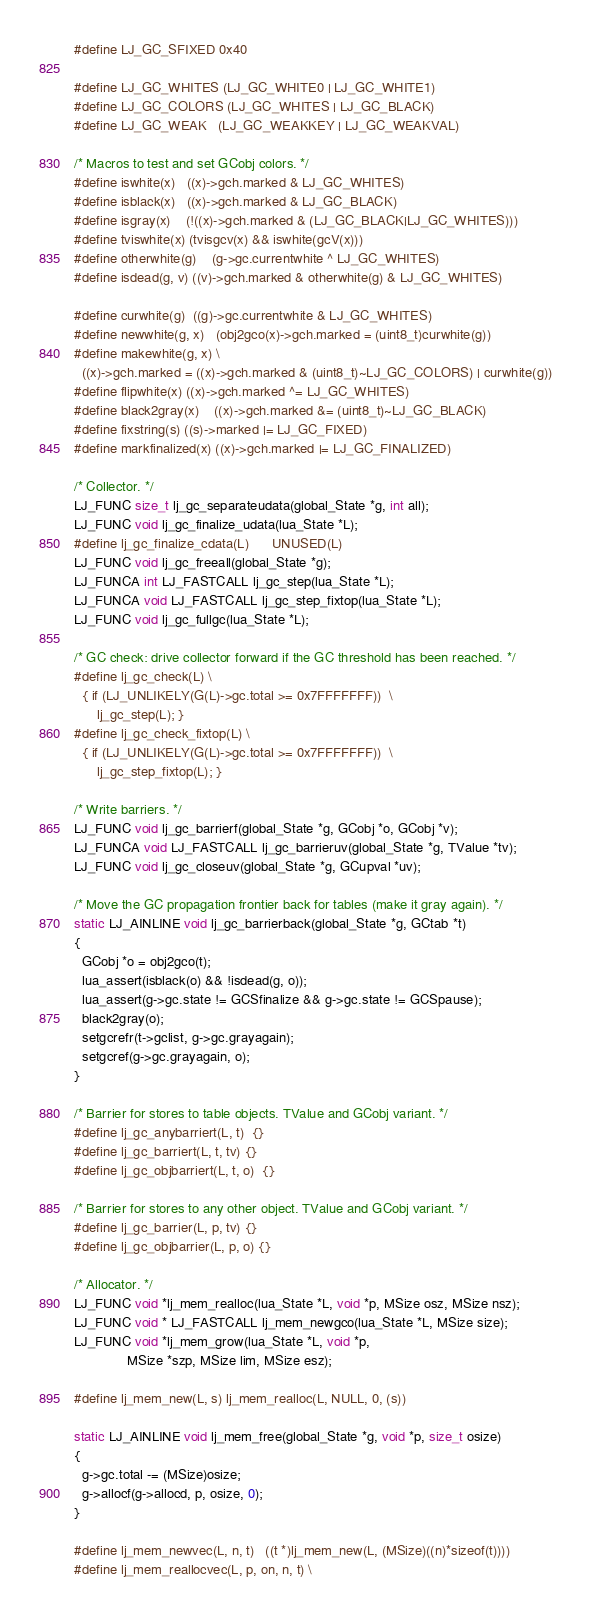Convert code to text. <code><loc_0><loc_0><loc_500><loc_500><_C_>#define LJ_GC_SFIXED	0x40

#define LJ_GC_WHITES	(LJ_GC_WHITE0 | LJ_GC_WHITE1)
#define LJ_GC_COLORS	(LJ_GC_WHITES | LJ_GC_BLACK)
#define LJ_GC_WEAK	(LJ_GC_WEAKKEY | LJ_GC_WEAKVAL)

/* Macros to test and set GCobj colors. */
#define iswhite(x)	((x)->gch.marked & LJ_GC_WHITES)
#define isblack(x)	((x)->gch.marked & LJ_GC_BLACK)
#define isgray(x)	(!((x)->gch.marked & (LJ_GC_BLACK|LJ_GC_WHITES)))
#define tviswhite(x)	(tvisgcv(x) && iswhite(gcV(x)))
#define otherwhite(g)	(g->gc.currentwhite ^ LJ_GC_WHITES)
#define isdead(g, v)	((v)->gch.marked & otherwhite(g) & LJ_GC_WHITES)

#define curwhite(g)	((g)->gc.currentwhite & LJ_GC_WHITES)
#define newwhite(g, x)	(obj2gco(x)->gch.marked = (uint8_t)curwhite(g))
#define makewhite(g, x) \
  ((x)->gch.marked = ((x)->gch.marked & (uint8_t)~LJ_GC_COLORS) | curwhite(g))
#define flipwhite(x)	((x)->gch.marked ^= LJ_GC_WHITES)
#define black2gray(x)	((x)->gch.marked &= (uint8_t)~LJ_GC_BLACK)
#define fixstring(s)	((s)->marked |= LJ_GC_FIXED)
#define markfinalized(x)	((x)->gch.marked |= LJ_GC_FINALIZED)

/* Collector. */
LJ_FUNC size_t lj_gc_separateudata(global_State *g, int all);
LJ_FUNC void lj_gc_finalize_udata(lua_State *L);
#define lj_gc_finalize_cdata(L)		UNUSED(L)
LJ_FUNC void lj_gc_freeall(global_State *g);
LJ_FUNCA int LJ_FASTCALL lj_gc_step(lua_State *L);
LJ_FUNCA void LJ_FASTCALL lj_gc_step_fixtop(lua_State *L);
LJ_FUNC void lj_gc_fullgc(lua_State *L);

/* GC check: drive collector forward if the GC threshold has been reached. */
#define lj_gc_check(L) \
  { if (LJ_UNLIKELY(G(L)->gc.total >= 0x7FFFFFFF))	\
      lj_gc_step(L); }
#define lj_gc_check_fixtop(L) \
  { if (LJ_UNLIKELY(G(L)->gc.total >= 0x7FFFFFFF))	\
      lj_gc_step_fixtop(L); }

/* Write barriers. */
LJ_FUNC void lj_gc_barrierf(global_State *g, GCobj *o, GCobj *v);
LJ_FUNCA void LJ_FASTCALL lj_gc_barrieruv(global_State *g, TValue *tv);
LJ_FUNC void lj_gc_closeuv(global_State *g, GCupval *uv);

/* Move the GC propagation frontier back for tables (make it gray again). */
static LJ_AINLINE void lj_gc_barrierback(global_State *g, GCtab *t)
{
  GCobj *o = obj2gco(t);
  lua_assert(isblack(o) && !isdead(g, o));
  lua_assert(g->gc.state != GCSfinalize && g->gc.state != GCSpause);
  black2gray(o);
  setgcrefr(t->gclist, g->gc.grayagain);
  setgcref(g->gc.grayagain, o);
}

/* Barrier for stores to table objects. TValue and GCobj variant. */
#define lj_gc_anybarriert(L, t)  {}
#define lj_gc_barriert(L, t, tv) {}
#define lj_gc_objbarriert(L, t, o)  {}

/* Barrier for stores to any other object. TValue and GCobj variant. */
#define lj_gc_barrier(L, p, tv) {}
#define lj_gc_objbarrier(L, p, o) {}

/* Allocator. */
LJ_FUNC void *lj_mem_realloc(lua_State *L, void *p, MSize osz, MSize nsz);
LJ_FUNC void * LJ_FASTCALL lj_mem_newgco(lua_State *L, MSize size);
LJ_FUNC void *lj_mem_grow(lua_State *L, void *p,
			  MSize *szp, MSize lim, MSize esz);

#define lj_mem_new(L, s)	lj_mem_realloc(L, NULL, 0, (s))

static LJ_AINLINE void lj_mem_free(global_State *g, void *p, size_t osize)
{
  g->gc.total -= (MSize)osize;
  g->allocf(g->allocd, p, osize, 0);
}

#define lj_mem_newvec(L, n, t)	((t *)lj_mem_new(L, (MSize)((n)*sizeof(t))))
#define lj_mem_reallocvec(L, p, on, n, t) \</code> 